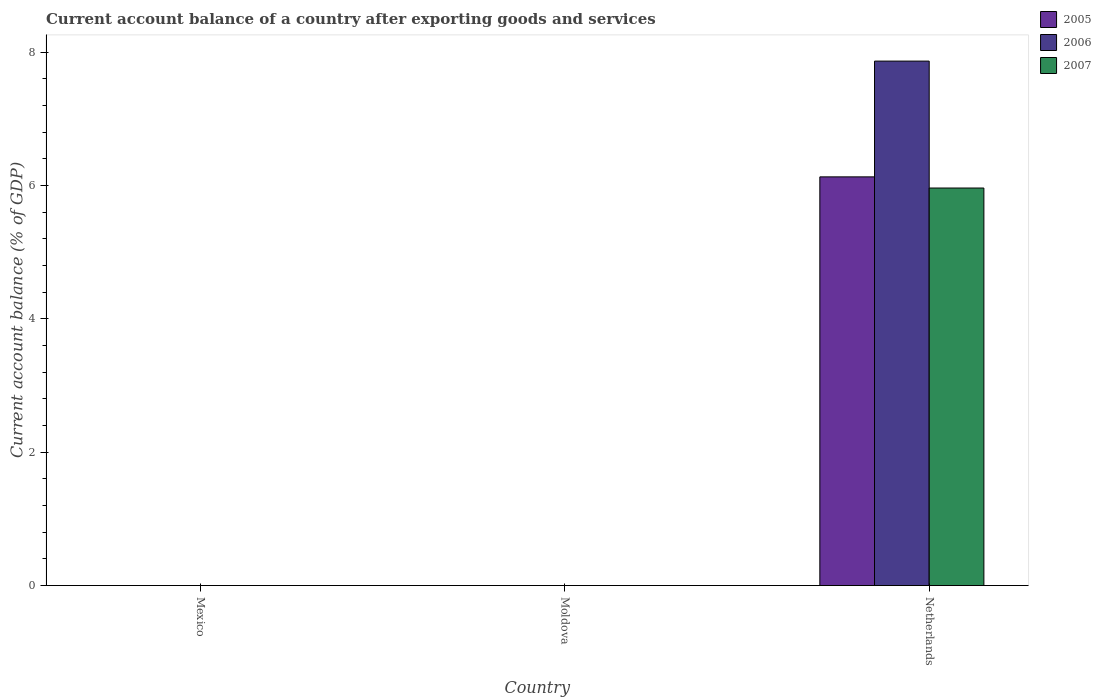How many different coloured bars are there?
Keep it short and to the point. 3. Are the number of bars on each tick of the X-axis equal?
Offer a terse response. No. How many bars are there on the 1st tick from the left?
Provide a succinct answer. 0. What is the label of the 1st group of bars from the left?
Keep it short and to the point. Mexico. What is the account balance in 2005 in Moldova?
Your answer should be compact. 0. Across all countries, what is the maximum account balance in 2007?
Offer a terse response. 5.96. What is the total account balance in 2007 in the graph?
Keep it short and to the point. 5.96. What is the difference between the account balance in 2006 in Netherlands and the account balance in 2007 in Mexico?
Offer a very short reply. 7.87. What is the average account balance in 2006 per country?
Provide a short and direct response. 2.62. What is the difference between the account balance of/in 2007 and account balance of/in 2005 in Netherlands?
Provide a succinct answer. -0.17. What is the difference between the highest and the lowest account balance in 2007?
Offer a terse response. 5.96. Is it the case that in every country, the sum of the account balance in 2007 and account balance in 2005 is greater than the account balance in 2006?
Ensure brevity in your answer.  No. Are all the bars in the graph horizontal?
Give a very brief answer. No. What is the difference between two consecutive major ticks on the Y-axis?
Keep it short and to the point. 2. Are the values on the major ticks of Y-axis written in scientific E-notation?
Keep it short and to the point. No. How many legend labels are there?
Your answer should be very brief. 3. How are the legend labels stacked?
Make the answer very short. Vertical. What is the title of the graph?
Your answer should be very brief. Current account balance of a country after exporting goods and services. Does "1981" appear as one of the legend labels in the graph?
Your answer should be compact. No. What is the label or title of the X-axis?
Ensure brevity in your answer.  Country. What is the label or title of the Y-axis?
Your response must be concise. Current account balance (% of GDP). What is the Current account balance (% of GDP) in 2005 in Mexico?
Offer a terse response. 0. What is the Current account balance (% of GDP) in 2006 in Mexico?
Your answer should be very brief. 0. What is the Current account balance (% of GDP) of 2007 in Mexico?
Offer a very short reply. 0. What is the Current account balance (% of GDP) in 2005 in Moldova?
Make the answer very short. 0. What is the Current account balance (% of GDP) in 2006 in Moldova?
Your answer should be compact. 0. What is the Current account balance (% of GDP) in 2005 in Netherlands?
Provide a short and direct response. 6.13. What is the Current account balance (% of GDP) in 2006 in Netherlands?
Your response must be concise. 7.87. What is the Current account balance (% of GDP) of 2007 in Netherlands?
Your answer should be very brief. 5.96. Across all countries, what is the maximum Current account balance (% of GDP) of 2005?
Offer a very short reply. 6.13. Across all countries, what is the maximum Current account balance (% of GDP) in 2006?
Your answer should be very brief. 7.87. Across all countries, what is the maximum Current account balance (% of GDP) of 2007?
Your response must be concise. 5.96. Across all countries, what is the minimum Current account balance (% of GDP) in 2005?
Provide a succinct answer. 0. Across all countries, what is the minimum Current account balance (% of GDP) in 2007?
Your response must be concise. 0. What is the total Current account balance (% of GDP) in 2005 in the graph?
Provide a short and direct response. 6.13. What is the total Current account balance (% of GDP) in 2006 in the graph?
Provide a short and direct response. 7.87. What is the total Current account balance (% of GDP) in 2007 in the graph?
Offer a terse response. 5.96. What is the average Current account balance (% of GDP) of 2005 per country?
Your response must be concise. 2.04. What is the average Current account balance (% of GDP) in 2006 per country?
Your answer should be compact. 2.62. What is the average Current account balance (% of GDP) in 2007 per country?
Make the answer very short. 1.99. What is the difference between the Current account balance (% of GDP) of 2005 and Current account balance (% of GDP) of 2006 in Netherlands?
Your answer should be compact. -1.74. What is the difference between the Current account balance (% of GDP) in 2005 and Current account balance (% of GDP) in 2007 in Netherlands?
Provide a short and direct response. 0.17. What is the difference between the Current account balance (% of GDP) in 2006 and Current account balance (% of GDP) in 2007 in Netherlands?
Offer a terse response. 1.9. What is the difference between the highest and the lowest Current account balance (% of GDP) of 2005?
Provide a succinct answer. 6.13. What is the difference between the highest and the lowest Current account balance (% of GDP) in 2006?
Provide a short and direct response. 7.87. What is the difference between the highest and the lowest Current account balance (% of GDP) in 2007?
Your response must be concise. 5.96. 